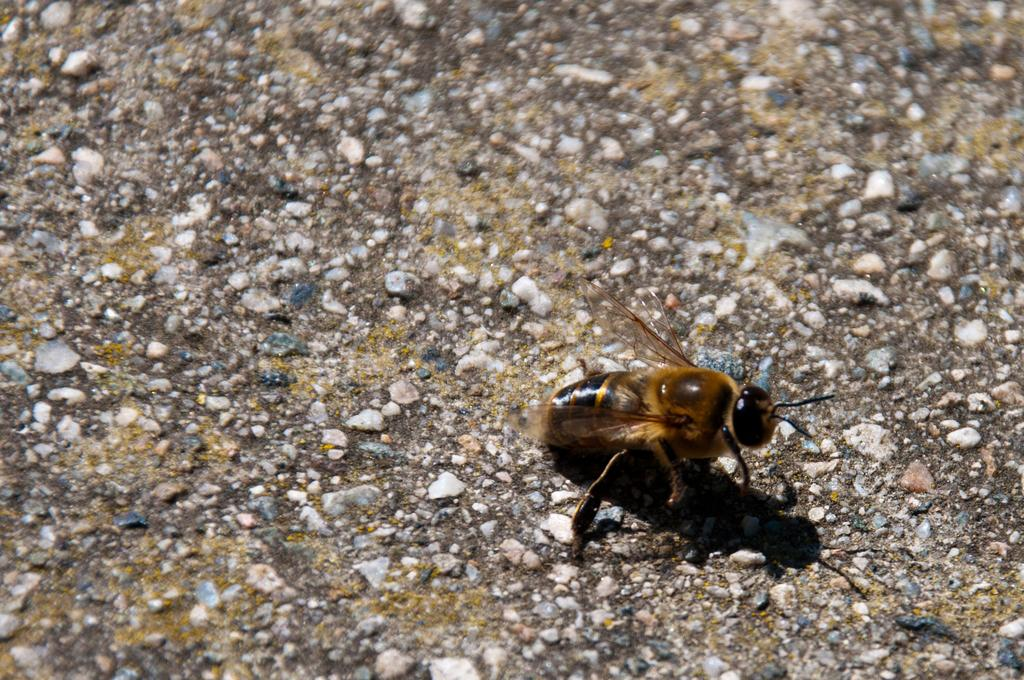What type of insect is in the picture? There is a honey bee in the picture. What colors can be seen on the honey bee? The honey bee is black and brown in color. What features are present on the honey bee's head? The honey bee has two antennas on its head. How many legs does the honey bee have? The honey bee has legs. What allows the honey bee to fly? The honey bee has wings. What can be found at the bottom of the picture? There are small stones at the bottom of the picture. Can you tell me how many ducks are swimming in the picture? There are no ducks present in the picture; it features a honey bee and small stones. What level of experience does the beginner honey bee have in the picture? There is no indication of the honey bee's experience level in the picture, as honey bees do not have a concept of beginner or expert. 